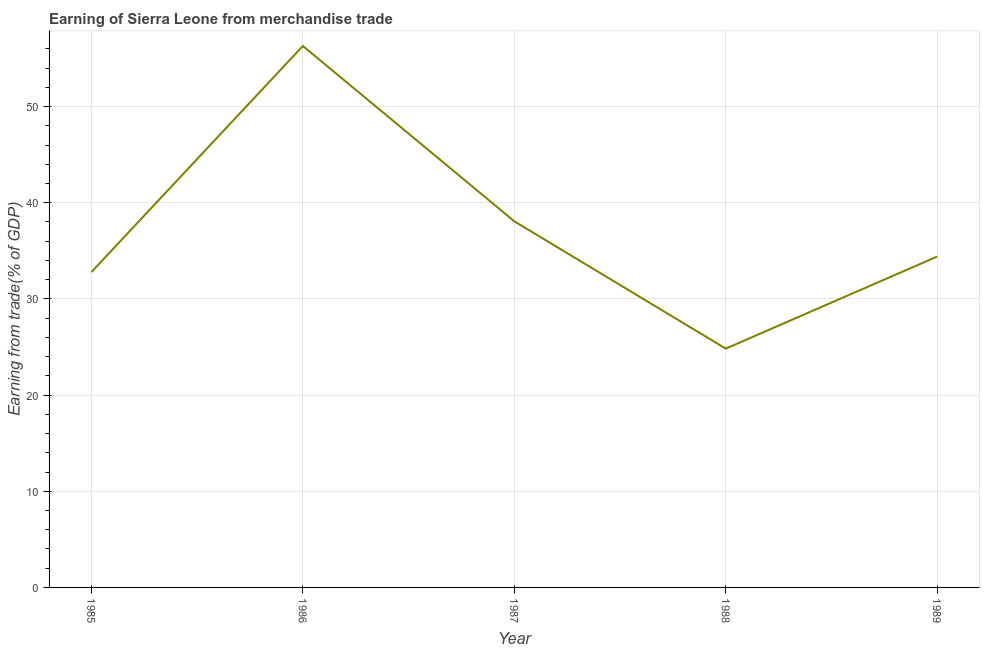What is the earning from merchandise trade in 1989?
Your response must be concise. 34.41. Across all years, what is the maximum earning from merchandise trade?
Your answer should be very brief. 56.31. Across all years, what is the minimum earning from merchandise trade?
Give a very brief answer. 24.83. In which year was the earning from merchandise trade maximum?
Make the answer very short. 1986. What is the sum of the earning from merchandise trade?
Offer a terse response. 186.41. What is the difference between the earning from merchandise trade in 1988 and 1989?
Ensure brevity in your answer.  -9.57. What is the average earning from merchandise trade per year?
Your answer should be very brief. 37.28. What is the median earning from merchandise trade?
Provide a succinct answer. 34.41. Do a majority of the years between 1989 and 1985 (inclusive) have earning from merchandise trade greater than 52 %?
Give a very brief answer. Yes. What is the ratio of the earning from merchandise trade in 1987 to that in 1989?
Offer a terse response. 1.11. Is the earning from merchandise trade in 1985 less than that in 1988?
Provide a short and direct response. No. What is the difference between the highest and the second highest earning from merchandise trade?
Provide a succinct answer. 18.23. What is the difference between the highest and the lowest earning from merchandise trade?
Give a very brief answer. 31.47. In how many years, is the earning from merchandise trade greater than the average earning from merchandise trade taken over all years?
Provide a succinct answer. 2. How many years are there in the graph?
Provide a succinct answer. 5. Are the values on the major ticks of Y-axis written in scientific E-notation?
Your answer should be very brief. No. Does the graph contain grids?
Offer a terse response. Yes. What is the title of the graph?
Provide a short and direct response. Earning of Sierra Leone from merchandise trade. What is the label or title of the X-axis?
Your answer should be very brief. Year. What is the label or title of the Y-axis?
Keep it short and to the point. Earning from trade(% of GDP). What is the Earning from trade(% of GDP) of 1985?
Your answer should be very brief. 32.79. What is the Earning from trade(% of GDP) of 1986?
Keep it short and to the point. 56.31. What is the Earning from trade(% of GDP) of 1987?
Offer a very short reply. 38.07. What is the Earning from trade(% of GDP) of 1988?
Make the answer very short. 24.83. What is the Earning from trade(% of GDP) of 1989?
Offer a very short reply. 34.41. What is the difference between the Earning from trade(% of GDP) in 1985 and 1986?
Make the answer very short. -23.51. What is the difference between the Earning from trade(% of GDP) in 1985 and 1987?
Provide a succinct answer. -5.28. What is the difference between the Earning from trade(% of GDP) in 1985 and 1988?
Ensure brevity in your answer.  7.96. What is the difference between the Earning from trade(% of GDP) in 1985 and 1989?
Provide a succinct answer. -1.61. What is the difference between the Earning from trade(% of GDP) in 1986 and 1987?
Give a very brief answer. 18.23. What is the difference between the Earning from trade(% of GDP) in 1986 and 1988?
Provide a short and direct response. 31.47. What is the difference between the Earning from trade(% of GDP) in 1986 and 1989?
Ensure brevity in your answer.  21.9. What is the difference between the Earning from trade(% of GDP) in 1987 and 1988?
Your response must be concise. 13.24. What is the difference between the Earning from trade(% of GDP) in 1987 and 1989?
Offer a very short reply. 3.67. What is the difference between the Earning from trade(% of GDP) in 1988 and 1989?
Your answer should be compact. -9.57. What is the ratio of the Earning from trade(% of GDP) in 1985 to that in 1986?
Your answer should be compact. 0.58. What is the ratio of the Earning from trade(% of GDP) in 1985 to that in 1987?
Your answer should be compact. 0.86. What is the ratio of the Earning from trade(% of GDP) in 1985 to that in 1988?
Your response must be concise. 1.32. What is the ratio of the Earning from trade(% of GDP) in 1985 to that in 1989?
Provide a short and direct response. 0.95. What is the ratio of the Earning from trade(% of GDP) in 1986 to that in 1987?
Give a very brief answer. 1.48. What is the ratio of the Earning from trade(% of GDP) in 1986 to that in 1988?
Offer a terse response. 2.27. What is the ratio of the Earning from trade(% of GDP) in 1986 to that in 1989?
Offer a very short reply. 1.64. What is the ratio of the Earning from trade(% of GDP) in 1987 to that in 1988?
Give a very brief answer. 1.53. What is the ratio of the Earning from trade(% of GDP) in 1987 to that in 1989?
Keep it short and to the point. 1.11. What is the ratio of the Earning from trade(% of GDP) in 1988 to that in 1989?
Provide a succinct answer. 0.72. 